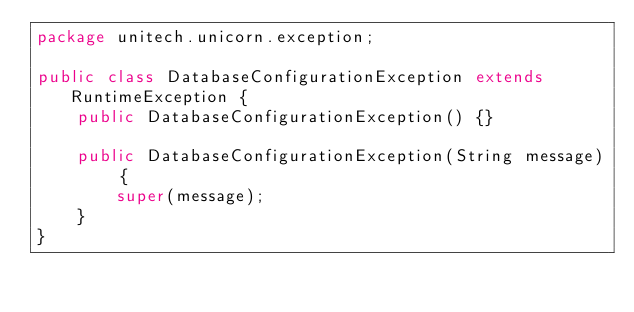<code> <loc_0><loc_0><loc_500><loc_500><_Java_>package unitech.unicorn.exception;

public class DatabaseConfigurationException extends RuntimeException {
    public DatabaseConfigurationException() {}

    public DatabaseConfigurationException(String message) {
        super(message);
    }
}
</code> 